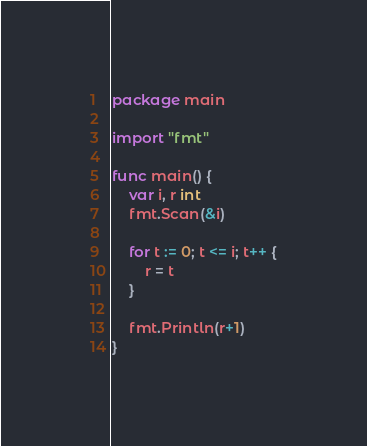Convert code to text. <code><loc_0><loc_0><loc_500><loc_500><_Go_>package main

import "fmt"

func main() {
	var i, r int
	fmt.Scan(&i)

	for t := 0; t <= i; t++ {
		r = t
	}

	fmt.Println(r+1)
}
</code> 